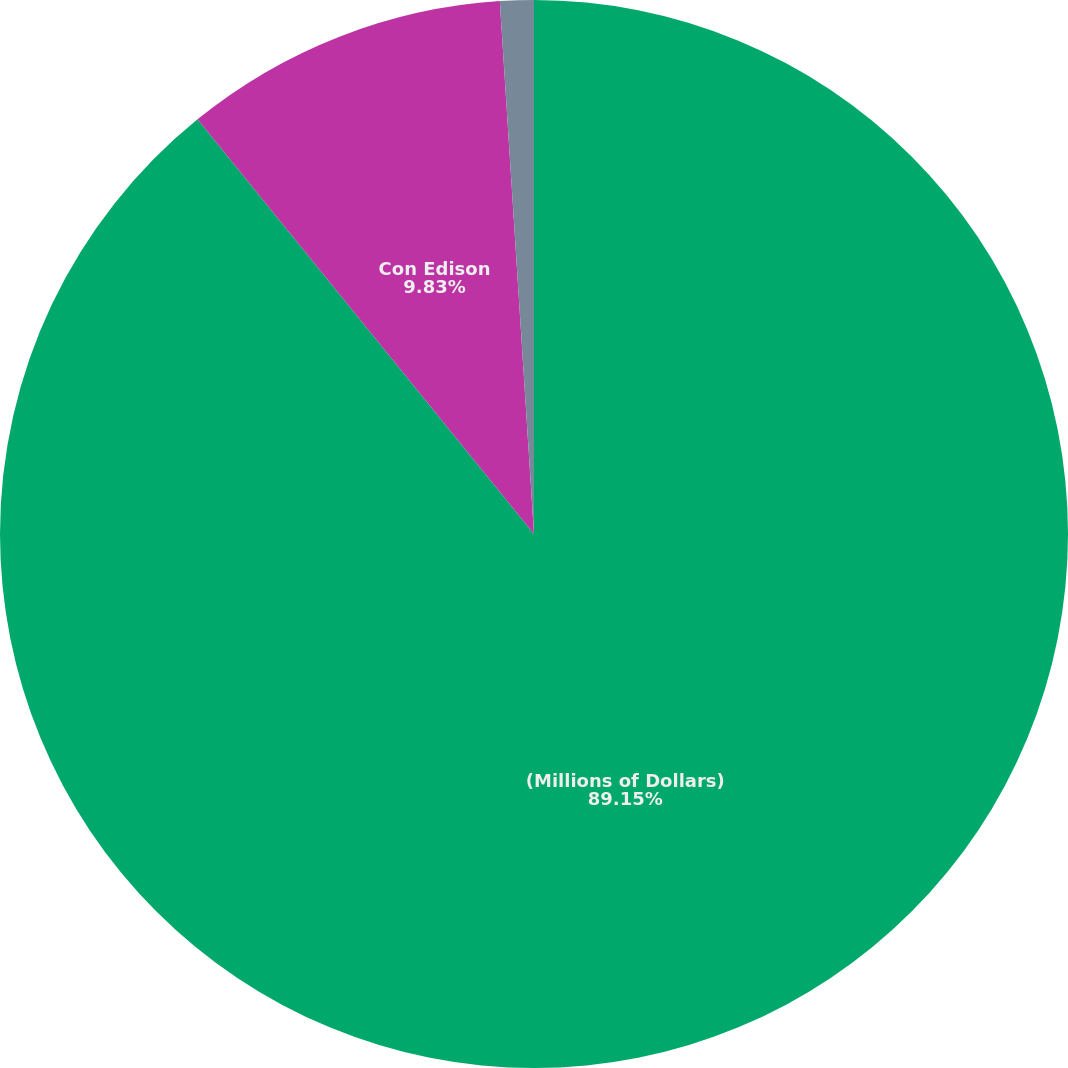Convert chart. <chart><loc_0><loc_0><loc_500><loc_500><pie_chart><fcel>(Millions of Dollars)<fcel>Con Edison<fcel>CECONY<nl><fcel>89.15%<fcel>9.83%<fcel>1.02%<nl></chart> 